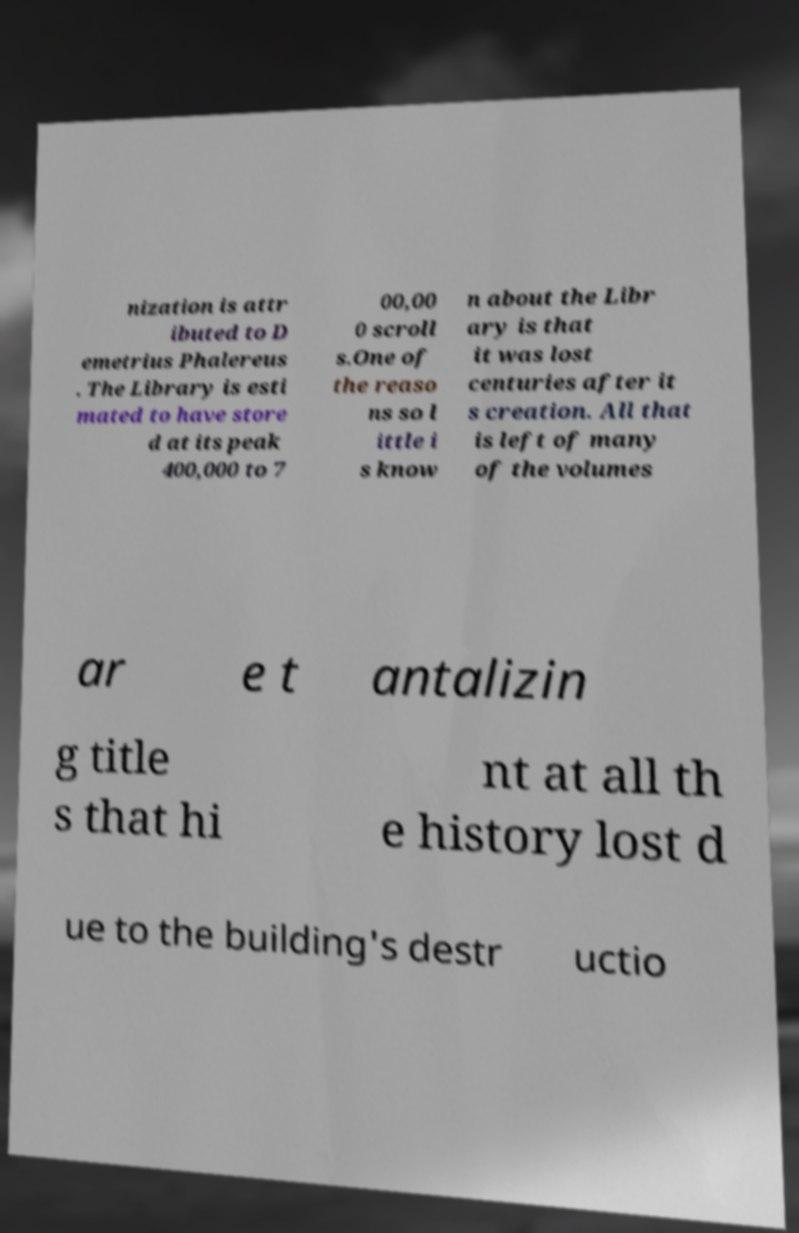I need the written content from this picture converted into text. Can you do that? nization is attr ibuted to D emetrius Phalereus . The Library is esti mated to have store d at its peak 400,000 to 7 00,00 0 scroll s.One of the reaso ns so l ittle i s know n about the Libr ary is that it was lost centuries after it s creation. All that is left of many of the volumes ar e t antalizin g title s that hi nt at all th e history lost d ue to the building's destr uctio 